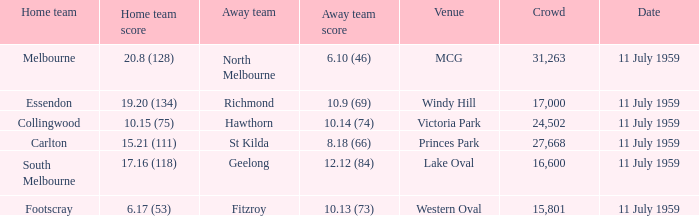What is the home team's score when richmond is away? 19.20 (134). 